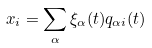<formula> <loc_0><loc_0><loc_500><loc_500>x _ { i } = \sum _ { \alpha } \xi _ { \alpha } ( t ) q _ { \alpha i } ( t )</formula> 